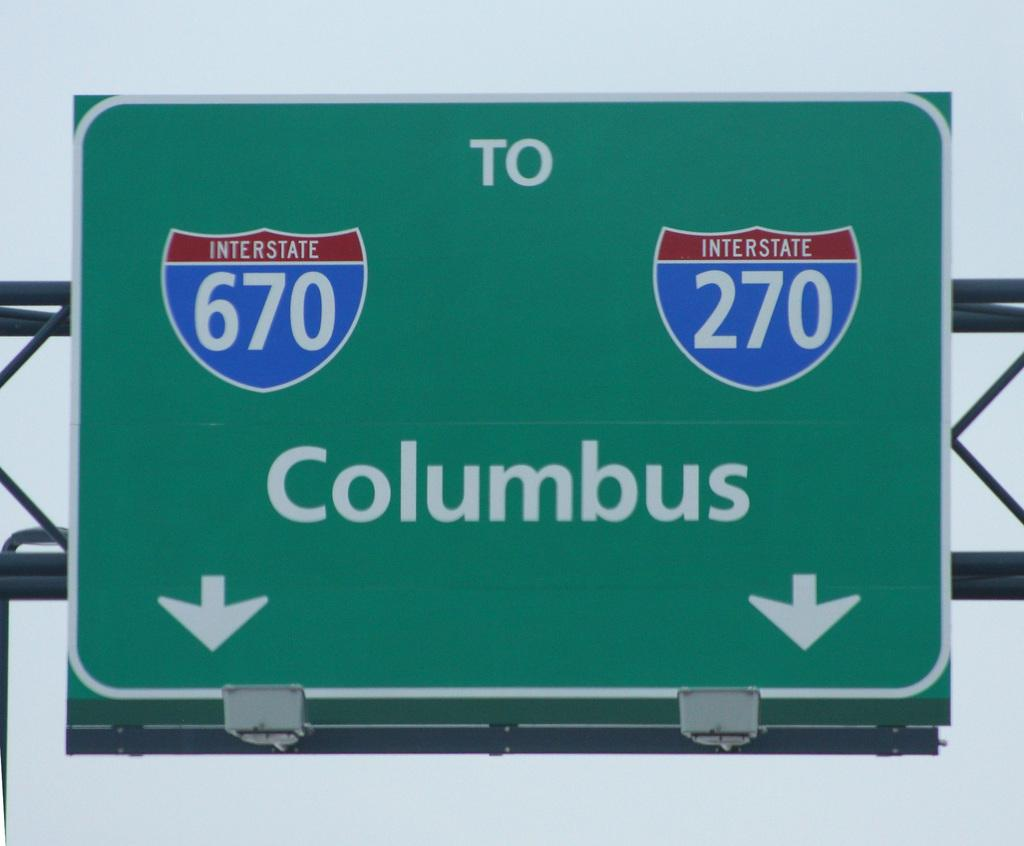<image>
Relay a brief, clear account of the picture shown. A green sign shows that interstates 670 and 260 lead to Columbus. 